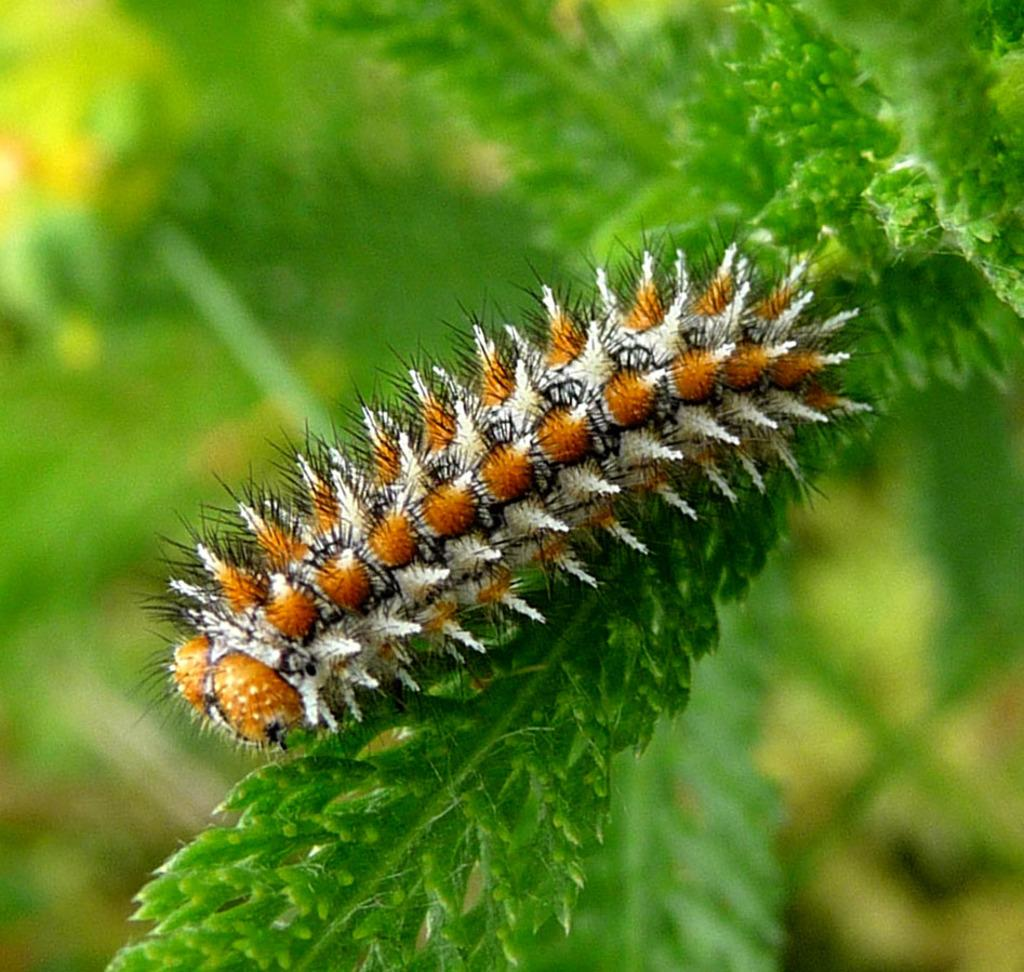What type of living organism can be seen on a plant in the image? There is an insect on a plant in the image. Can you describe the background of the image? The background of the image is blurred. How many ants are visible on the plant in the image? There are no ants visible on the plant in the image; only one insect is present. What message of peace can be seen in the image? There is no message of peace present in the image; it features an insect on a plant and a blurred background. What type of animal is grazing in the background of the image? There is no animal, such as a horse, present in the image; it only features an insect on a plant and a blurred background. 